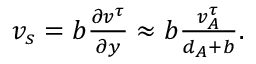Convert formula to latex. <formula><loc_0><loc_0><loc_500><loc_500>\begin{array} { r } { v _ { s } = b \frac { \partial v ^ { \tau } } { \partial y } \approx b \frac { v _ { A } ^ { \tau } } { d _ { A } + b } . } \end{array}</formula> 